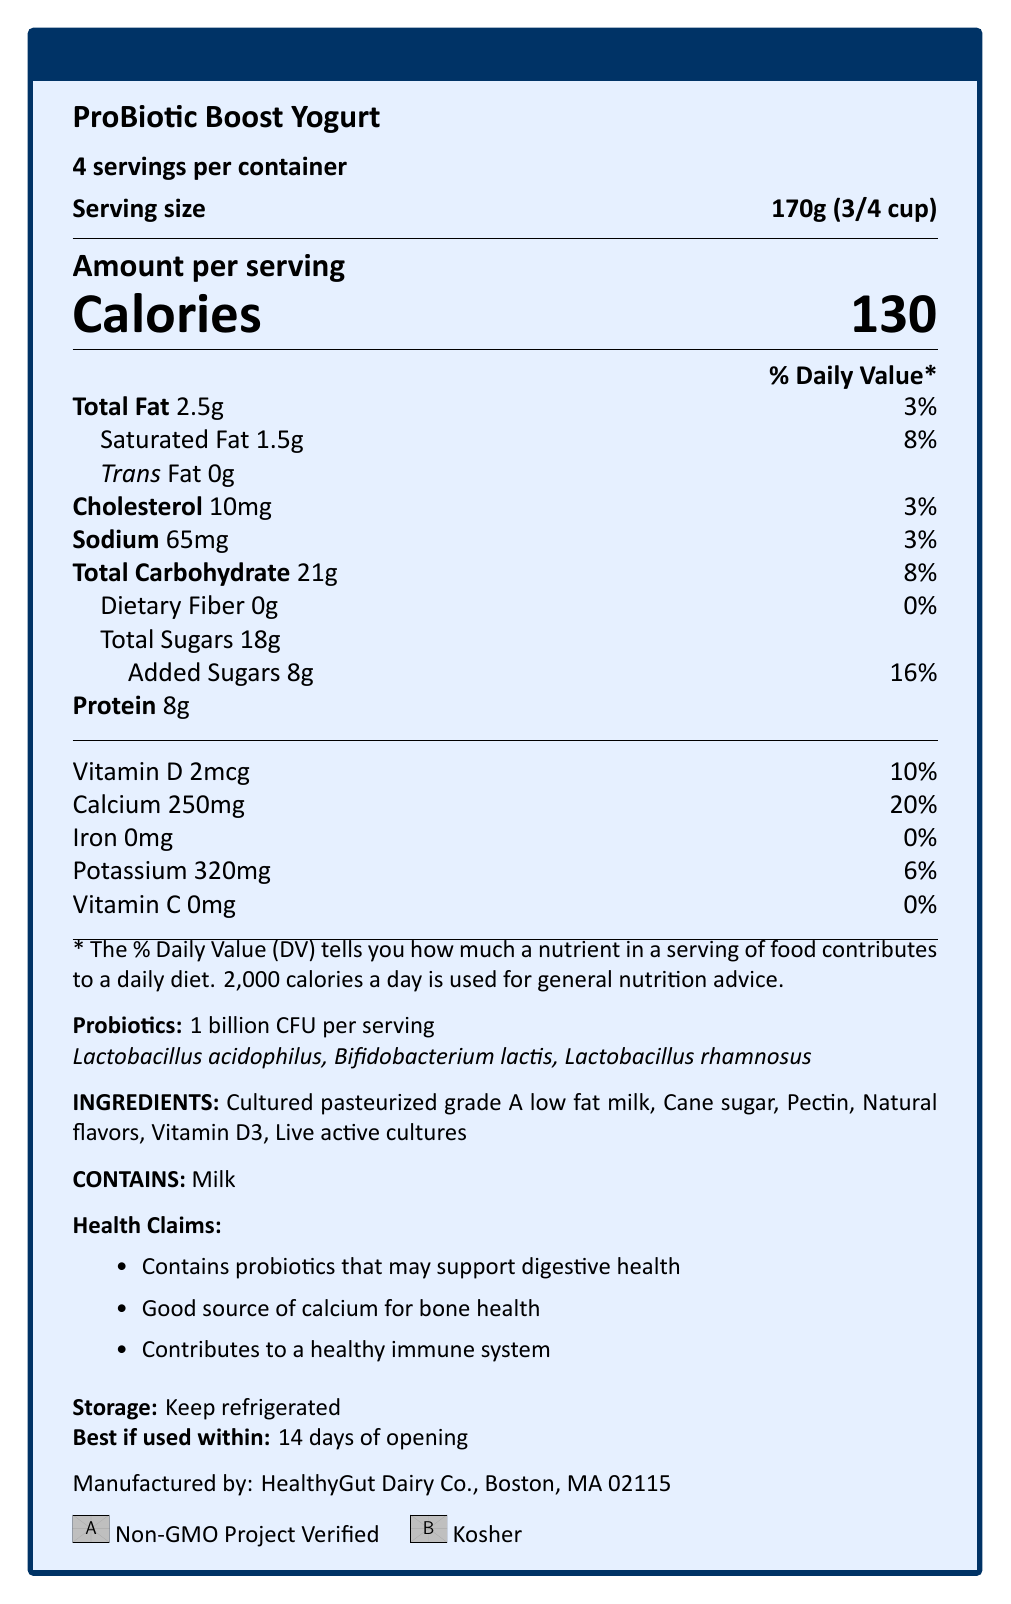what is the serving size? The serving size is clearly indicated in the document as 170g (3/4 cup).
Answer: 170g (3/4 cup) how many servings are in a container? The document specifies that there are 4 servings per container.
Answer: 4 how many calories are in one serving? The document prominently shows that there are 130 calories per serving.
Answer: 130 what is the daily value percentage of saturated fat? The daily value percentage of saturated fat is mentioned as 8% in the document.
Answer: 8% which probiotic strains are included in this yogurt? The document lists these strains under the probiotics section.
Answer: Lactobacillus acidophilus, Bifidobacterium lactis, Lactobacillus rhamnosus what is the manufacturer of this product? The manufacturer details are provided at the end of the document.
Answer: HealthyGut Dairy Co., Boston, MA 02115 how much calcium is in one serving and what is the daily value percentage? The document lists 250mg of calcium per serving with a daily value percentage of 20%.
Answer: 250mg, 20% what is the total amount of sugars in one serving? The document specifies that the total sugars amount to 18g per serving.
Answer: 18g what is the expiration date after opening? The expiration date is mentioned clearly in the document.
Answer: Best if used within 14 days of opening how much protein is in one serving? The document states that one serving contains 8g of protein.
Answer: 8g how many billion CFU of probiotics are in one serving? The document mentions that each serving contains 1 billion CFU of probiotics.
Answer: 1 billion CFU per serving what are some of the health claims mentioned for this yogurt? The document lists these specific health claims.
Answer: Contains probiotics that may support digestive health, Good source of calcium for bone health, Contributes to a healthy immune system what are the storage instructions for this yogurt? The storage instructions are clearly mentioned in the document.
Answer: Keep refrigerated what are the allergens listed for this yogurt? The document states that the product contains milk.
Answer: Contains milk what is the percentage daily value of sodium in one serving? According to the document, the daily value percentage for sodium is 3%.
Answer: 3% how many grams of total fat are there per serving and what is the percentage daily value? The document lists the total fat content as 2.5g per serving with a daily value percentage of 3%.
Answer: 2.5g, 3% what is the main idea of the document? The document contains specific information about the serving size, calories, nutrient percentages, probiotic content, health claims, ingredients, and storage instructions, giving a comprehensive overview of the yogurt's nutritional profile.
Answer: The document provides detailed nutrition facts, ingredients, and health claims for ProBiotic Boost Yogurt, highlighting its probiotics for gut health and immune support, nutritional content including vitamins and minerals, and storage instructions. how much cholesterol is in one serving? The document specifies that there are 10mg of cholesterol per serving.
Answer: 10mg which of the following vitamins are included in this yogurt? A. Vitamin A B. Vitamin B12 C. Vitamin D D. Vitamin E The document lists vitamin D among the nutrients, but not vitamins A, B12, or E.
Answer: C. Vitamin D which certification does the yogurt have? A. USDA Organic B. Gluten-Free C. Non-GMO Project Verified The document mentions that the yogurt is Non-GMO Project Verified and does not list USDA Organic or Gluten-Free certifications.
Answer: C. Non-GMO Project Verified does this yogurt have any added sugars? The document specifies that there are 8g of added sugars per serving.
Answer: Yes is it stated whether this yogurt is safe for lacto-vegetarian diet? The document does not provide any specific information regarding the suitability for a lacto-vegetarian diet.
Answer: Not enough information 